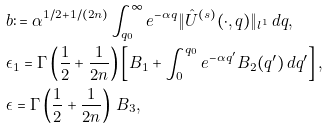<formula> <loc_0><loc_0><loc_500><loc_500>& b \colon = \alpha ^ { 1 / 2 + 1 / ( 2 n ) } \int _ { q _ { 0 } } ^ { \infty } e ^ { - \alpha q } \| \hat { U } ^ { ( s ) } ( \cdot , q ) \| _ { l ^ { 1 } } \, d q , \\ & \epsilon _ { 1 } = \Gamma \left ( \frac { 1 } { 2 } + \frac { 1 } { 2 n } \right ) \left [ B _ { 1 } + \int _ { 0 } ^ { q _ { 0 } } e ^ { - \alpha q ^ { \prime } } B _ { 2 } ( q ^ { \prime } ) \, d q ^ { \prime } \right ] , \\ & \epsilon = \Gamma \left ( \frac { 1 } { 2 } + \frac { 1 } { 2 n } \right ) \, B _ { 3 } ,</formula> 